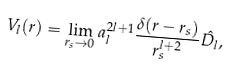<formula> <loc_0><loc_0><loc_500><loc_500>V _ { l } ( r ) = \lim _ { r _ { s } \rightarrow 0 } a _ { l } ^ { 2 l + 1 } \frac { \delta ( r - r _ { s } ) } { r _ { s } ^ { l + 2 } } \hat { D _ { l } } ,</formula> 